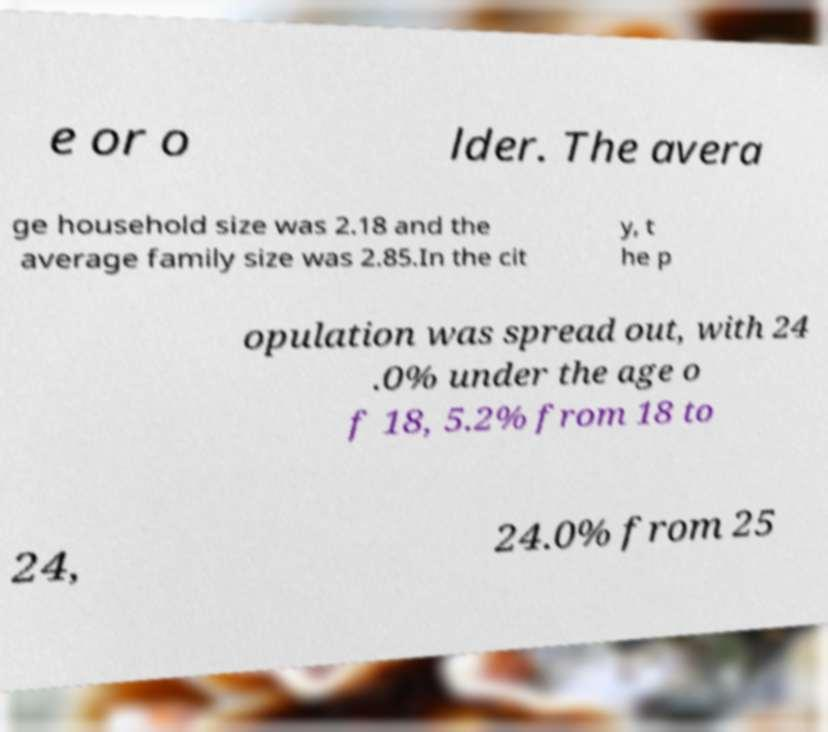There's text embedded in this image that I need extracted. Can you transcribe it verbatim? e or o lder. The avera ge household size was 2.18 and the average family size was 2.85.In the cit y, t he p opulation was spread out, with 24 .0% under the age o f 18, 5.2% from 18 to 24, 24.0% from 25 